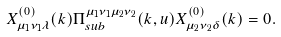<formula> <loc_0><loc_0><loc_500><loc_500>X _ { \mu _ { 1 } \nu _ { 1 } \lambda } ^ { ( 0 ) } ( k ) \Pi _ { s u b } ^ { \mu _ { 1 } \nu _ { 1 } \mu _ { 2 } \nu _ { 2 } } ( k , u ) X _ { \mu _ { 2 } \nu _ { 2 } \delta } ^ { ( 0 ) } ( k ) = 0 .</formula> 